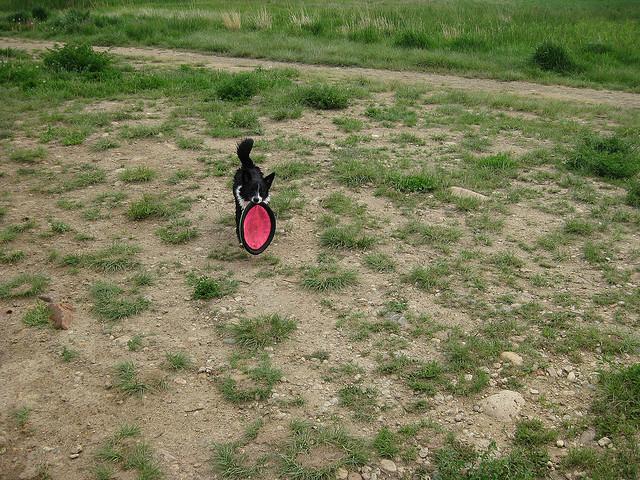How old is the dog?
Answer briefly. 7. Is the dog on a road?
Concise answer only. No. What color is the disk?
Be succinct. Red. Did the dog just catch a frisbee?
Give a very brief answer. Yes. Is the dog going to give the Frisbee back?
Quick response, please. Yes. Is the man in a park?
Concise answer only. No. 